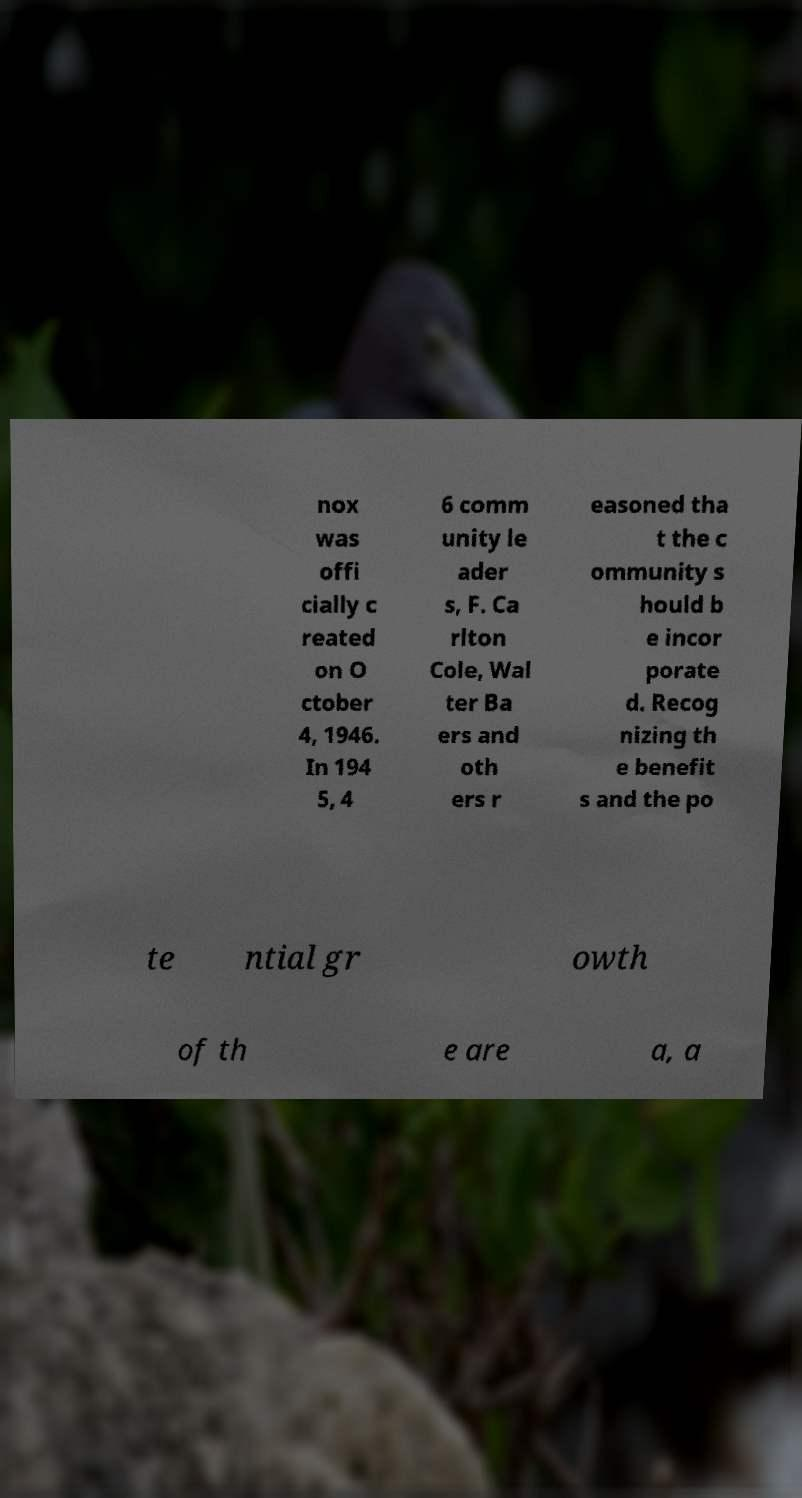There's text embedded in this image that I need extracted. Can you transcribe it verbatim? nox was offi cially c reated on O ctober 4, 1946. In 194 5, 4 6 comm unity le ader s, F. Ca rlton Cole, Wal ter Ba ers and oth ers r easoned tha t the c ommunity s hould b e incor porate d. Recog nizing th e benefit s and the po te ntial gr owth of th e are a, a 